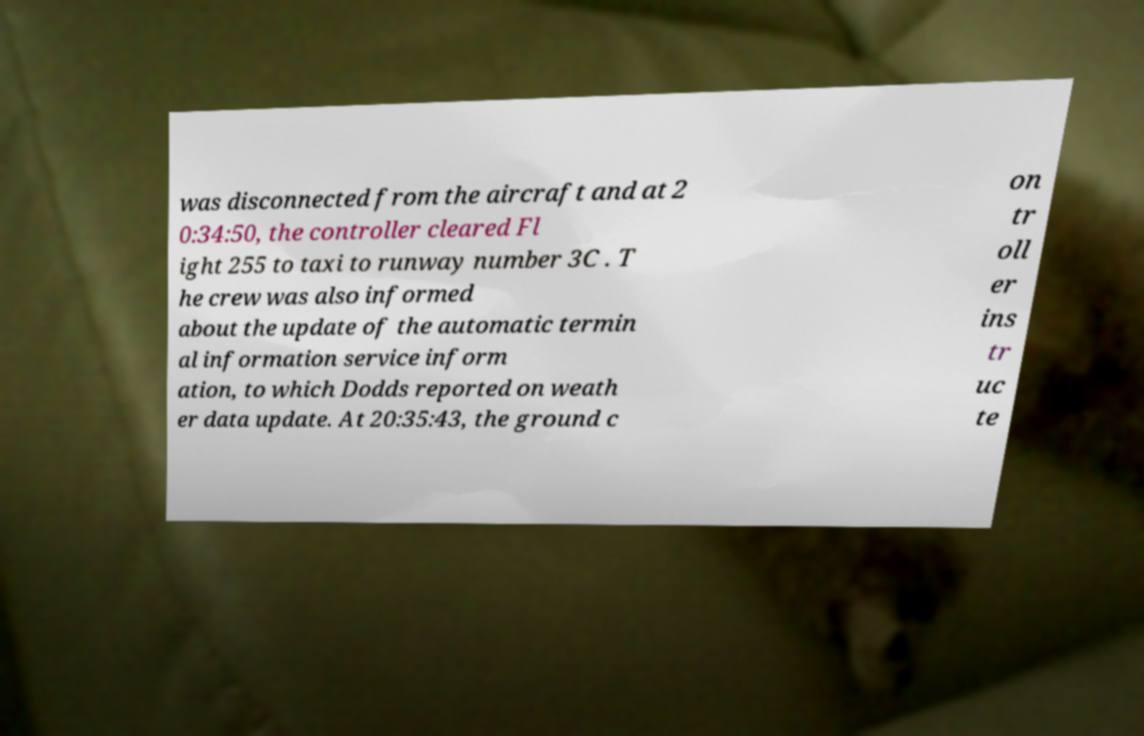Please identify and transcribe the text found in this image. was disconnected from the aircraft and at 2 0:34:50, the controller cleared Fl ight 255 to taxi to runway number 3C . T he crew was also informed about the update of the automatic termin al information service inform ation, to which Dodds reported on weath er data update. At 20:35:43, the ground c on tr oll er ins tr uc te 